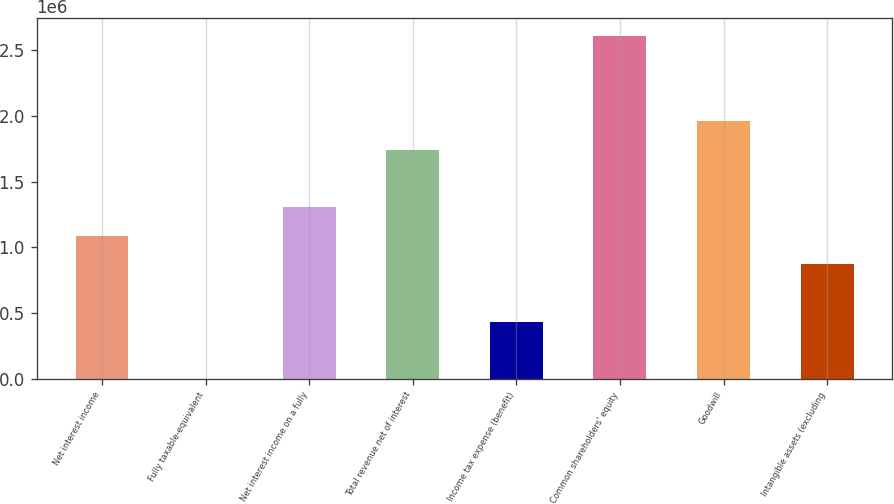<chart> <loc_0><loc_0><loc_500><loc_500><bar_chart><fcel>Net interest income<fcel>Fully taxable-equivalent<fcel>Net interest income on a fully<fcel>Total revenue net of interest<fcel>Income tax expense (benefit)<fcel>Common shareholders' equity<fcel>Goodwill<fcel>Intangible assets (excluding<nl><fcel>1.08752e+06<fcel>211<fcel>1.30498e+06<fcel>1.7399e+06<fcel>435133<fcel>2.60974e+06<fcel>1.95736e+06<fcel>870054<nl></chart> 